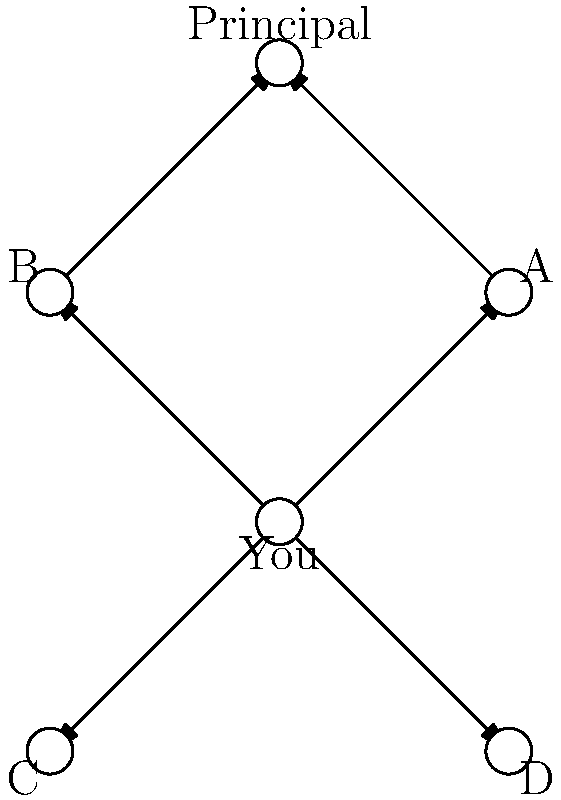In the social network graph of Leto High School's Class of 1979, you are represented by the central node. The graph shows your connections to classmates A, B, C, and D, as well as to the Principal. What is the minimum number of intermediaries needed to relay a message from you to the Principal without directly interacting with them? To solve this problem, we need to analyze the graph and find the shortest path from "You" to the "Principal" that involves intermediaries. Let's break it down step-by-step:

1. First, observe that there is no direct connection between "You" and the "Principal".

2. We need to find a path that goes through other nodes (classmates) to reach the Principal.

3. Looking at the graph, we can see that there are two possible paths:
   a. You -> A -> Principal
   b. You -> B -> Principal

4. Both paths involve one intermediary (either A or B).

5. Since we're asked for the minimum number of intermediaries, and both valid paths use only one intermediary, the answer is 1.

This minimum number of intermediaries (1) represents the shortest indirect communication channel between you and the Principal, which might be interpreted as a way to avoid direct interaction, fitting the persona of someone who disliked their high school experience.
Answer: 1 